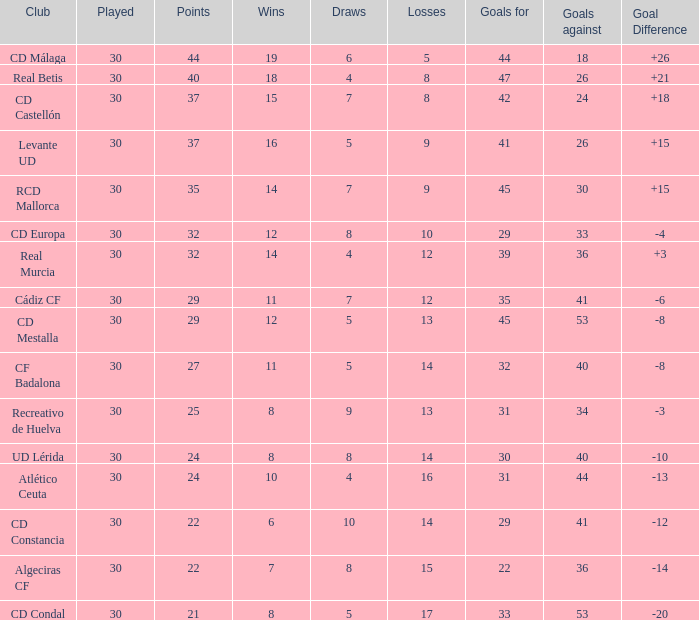When played exceeds 30, what are the aims? None. 